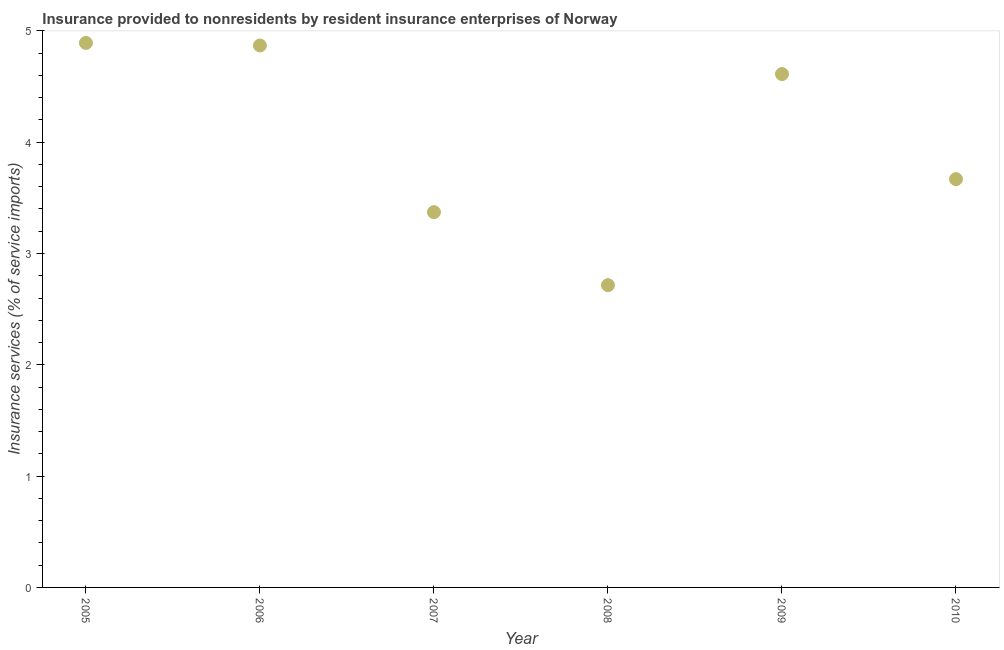What is the insurance and financial services in 2007?
Make the answer very short. 3.37. Across all years, what is the maximum insurance and financial services?
Your response must be concise. 4.89. Across all years, what is the minimum insurance and financial services?
Make the answer very short. 2.72. In which year was the insurance and financial services maximum?
Your answer should be very brief. 2005. In which year was the insurance and financial services minimum?
Ensure brevity in your answer.  2008. What is the sum of the insurance and financial services?
Offer a very short reply. 24.13. What is the difference between the insurance and financial services in 2005 and 2009?
Your answer should be compact. 0.28. What is the average insurance and financial services per year?
Your response must be concise. 4.02. What is the median insurance and financial services?
Offer a very short reply. 4.14. In how many years, is the insurance and financial services greater than 2.8 %?
Give a very brief answer. 5. What is the ratio of the insurance and financial services in 2008 to that in 2009?
Offer a very short reply. 0.59. What is the difference between the highest and the second highest insurance and financial services?
Offer a very short reply. 0.02. Is the sum of the insurance and financial services in 2006 and 2008 greater than the maximum insurance and financial services across all years?
Provide a short and direct response. Yes. What is the difference between the highest and the lowest insurance and financial services?
Make the answer very short. 2.18. In how many years, is the insurance and financial services greater than the average insurance and financial services taken over all years?
Provide a short and direct response. 3. How many dotlines are there?
Provide a succinct answer. 1. How many years are there in the graph?
Provide a succinct answer. 6. Are the values on the major ticks of Y-axis written in scientific E-notation?
Keep it short and to the point. No. Does the graph contain grids?
Offer a very short reply. No. What is the title of the graph?
Provide a succinct answer. Insurance provided to nonresidents by resident insurance enterprises of Norway. What is the label or title of the X-axis?
Your answer should be compact. Year. What is the label or title of the Y-axis?
Your answer should be compact. Insurance services (% of service imports). What is the Insurance services (% of service imports) in 2005?
Your answer should be compact. 4.89. What is the Insurance services (% of service imports) in 2006?
Provide a short and direct response. 4.87. What is the Insurance services (% of service imports) in 2007?
Offer a very short reply. 3.37. What is the Insurance services (% of service imports) in 2008?
Make the answer very short. 2.72. What is the Insurance services (% of service imports) in 2009?
Keep it short and to the point. 4.61. What is the Insurance services (% of service imports) in 2010?
Ensure brevity in your answer.  3.67. What is the difference between the Insurance services (% of service imports) in 2005 and 2006?
Provide a short and direct response. 0.02. What is the difference between the Insurance services (% of service imports) in 2005 and 2007?
Your answer should be compact. 1.52. What is the difference between the Insurance services (% of service imports) in 2005 and 2008?
Your response must be concise. 2.18. What is the difference between the Insurance services (% of service imports) in 2005 and 2009?
Ensure brevity in your answer.  0.28. What is the difference between the Insurance services (% of service imports) in 2005 and 2010?
Give a very brief answer. 1.22. What is the difference between the Insurance services (% of service imports) in 2006 and 2007?
Give a very brief answer. 1.5. What is the difference between the Insurance services (% of service imports) in 2006 and 2008?
Keep it short and to the point. 2.15. What is the difference between the Insurance services (% of service imports) in 2006 and 2009?
Offer a terse response. 0.26. What is the difference between the Insurance services (% of service imports) in 2006 and 2010?
Offer a very short reply. 1.2. What is the difference between the Insurance services (% of service imports) in 2007 and 2008?
Your answer should be compact. 0.66. What is the difference between the Insurance services (% of service imports) in 2007 and 2009?
Provide a succinct answer. -1.24. What is the difference between the Insurance services (% of service imports) in 2007 and 2010?
Offer a very short reply. -0.3. What is the difference between the Insurance services (% of service imports) in 2008 and 2009?
Offer a terse response. -1.9. What is the difference between the Insurance services (% of service imports) in 2008 and 2010?
Provide a short and direct response. -0.95. What is the difference between the Insurance services (% of service imports) in 2009 and 2010?
Ensure brevity in your answer.  0.94. What is the ratio of the Insurance services (% of service imports) in 2005 to that in 2006?
Offer a terse response. 1. What is the ratio of the Insurance services (% of service imports) in 2005 to that in 2007?
Your answer should be very brief. 1.45. What is the ratio of the Insurance services (% of service imports) in 2005 to that in 2008?
Provide a short and direct response. 1.8. What is the ratio of the Insurance services (% of service imports) in 2005 to that in 2009?
Your answer should be very brief. 1.06. What is the ratio of the Insurance services (% of service imports) in 2005 to that in 2010?
Your answer should be very brief. 1.33. What is the ratio of the Insurance services (% of service imports) in 2006 to that in 2007?
Keep it short and to the point. 1.44. What is the ratio of the Insurance services (% of service imports) in 2006 to that in 2008?
Provide a short and direct response. 1.79. What is the ratio of the Insurance services (% of service imports) in 2006 to that in 2009?
Your answer should be compact. 1.06. What is the ratio of the Insurance services (% of service imports) in 2006 to that in 2010?
Your answer should be very brief. 1.33. What is the ratio of the Insurance services (% of service imports) in 2007 to that in 2008?
Keep it short and to the point. 1.24. What is the ratio of the Insurance services (% of service imports) in 2007 to that in 2009?
Provide a short and direct response. 0.73. What is the ratio of the Insurance services (% of service imports) in 2007 to that in 2010?
Offer a terse response. 0.92. What is the ratio of the Insurance services (% of service imports) in 2008 to that in 2009?
Provide a short and direct response. 0.59. What is the ratio of the Insurance services (% of service imports) in 2008 to that in 2010?
Provide a short and direct response. 0.74. What is the ratio of the Insurance services (% of service imports) in 2009 to that in 2010?
Your answer should be compact. 1.26. 